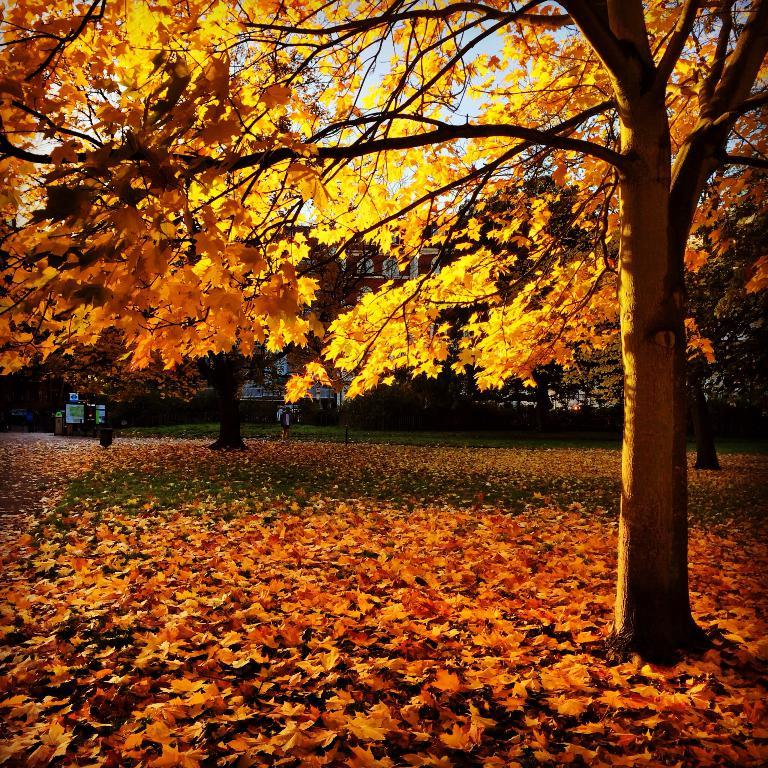What type of vegetation can be seen in the image? There is a group of trees in the image. What is on the ground beneath the trees? There are leaves on the ground in the image. What can be seen in the distance behind the trees? There is a building in the background of the image. What is visible above the trees and building? The sky is visible in the background of the image. Can you touch your mom in the image? There is no person, including a mom, present in the image. 